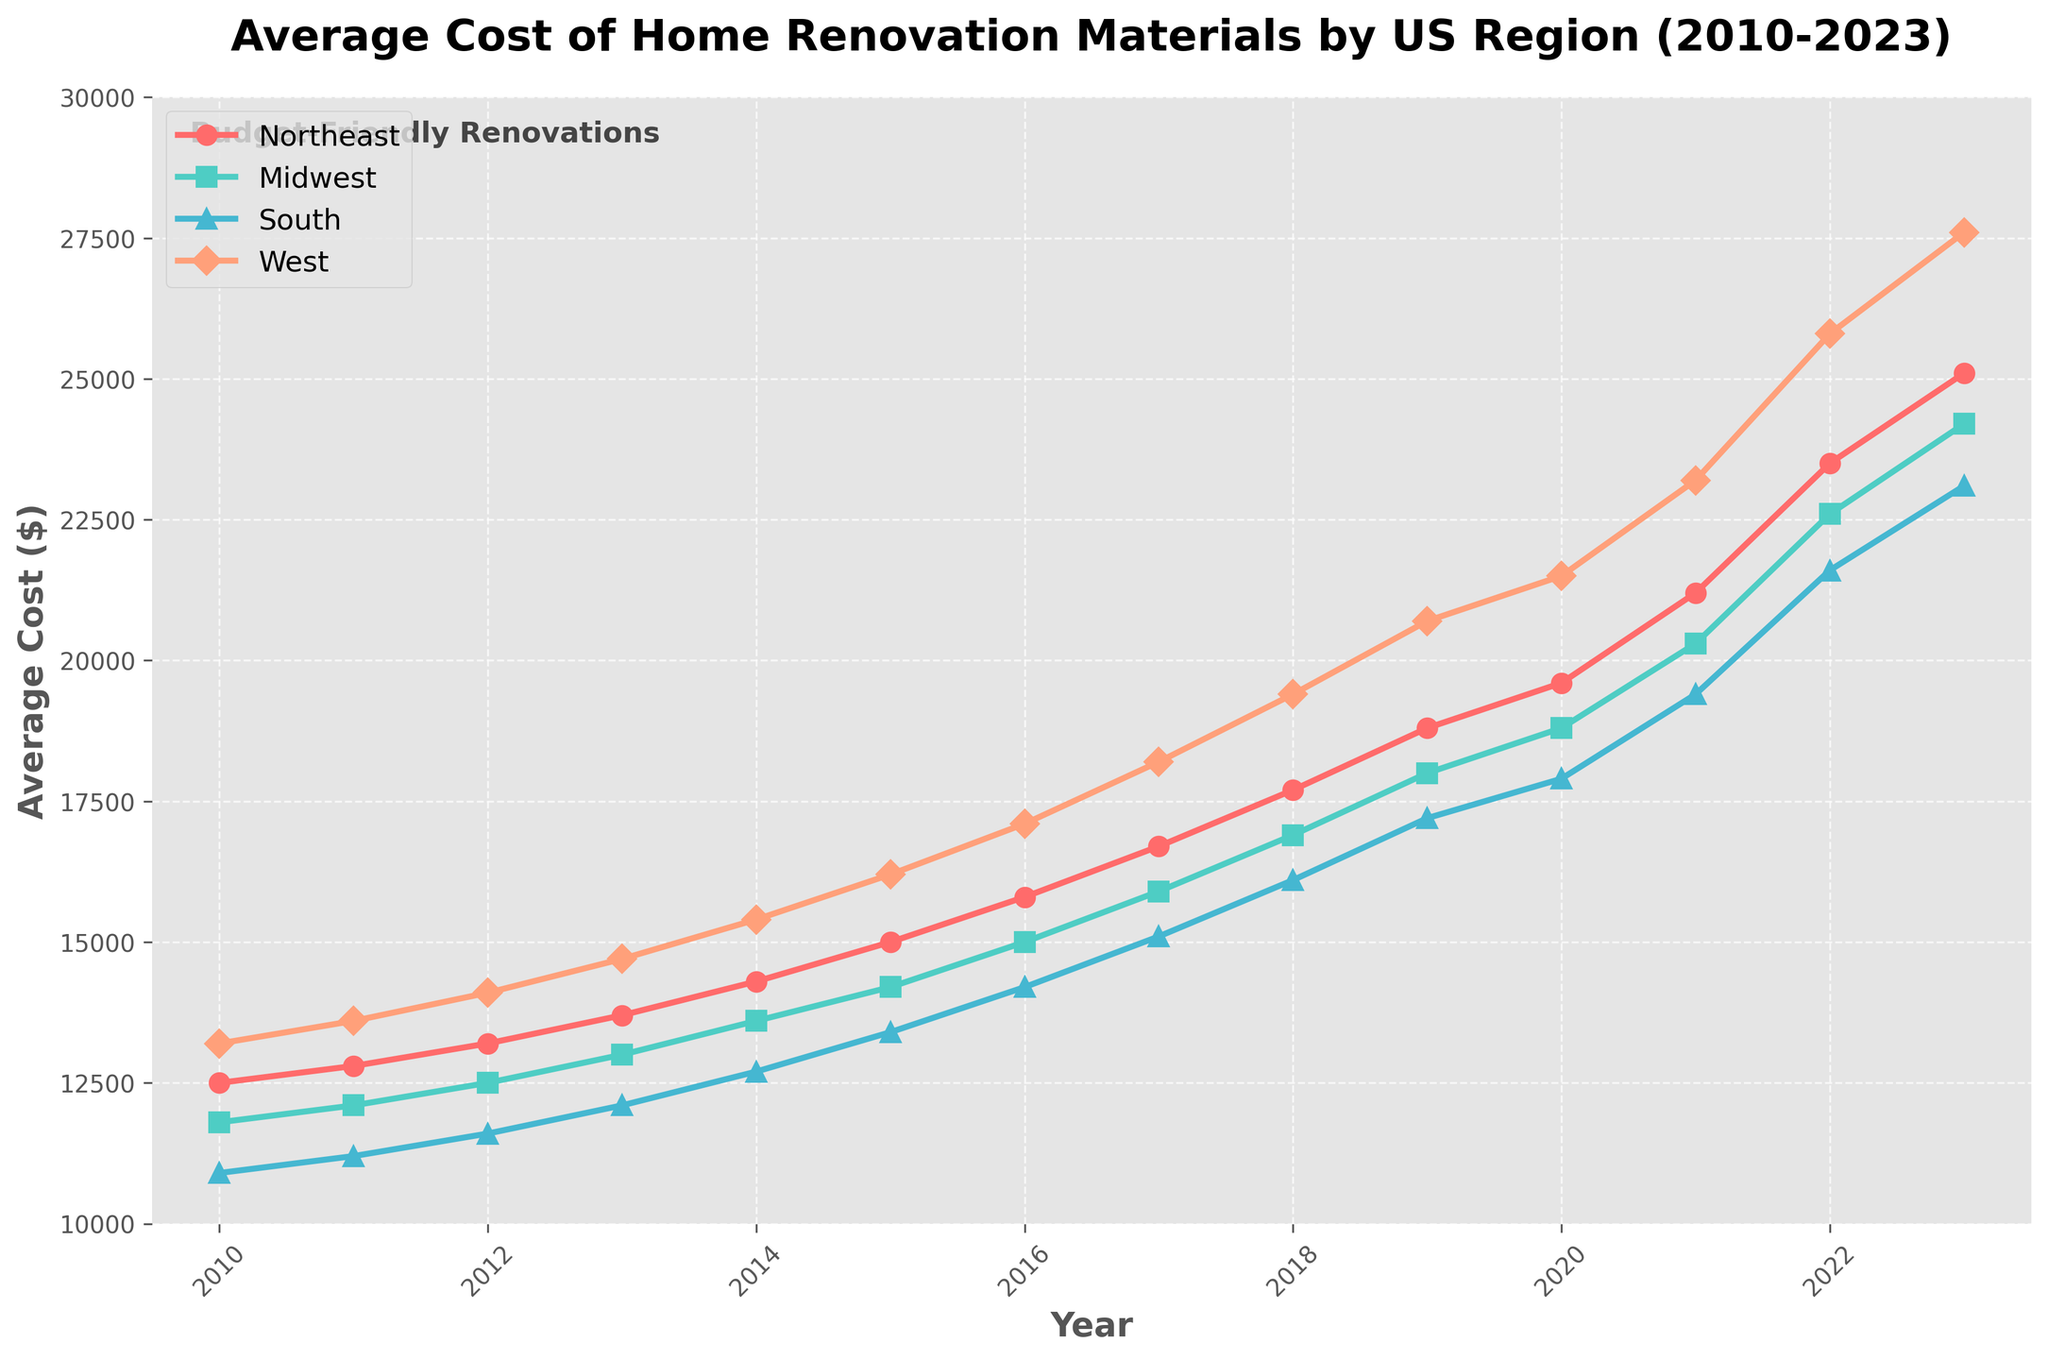What was the average cost of renovation materials in the West region in 2023? To find this, look at the value on the y-axis corresponding to the year 2023 in the West region (orange line). The value is 27600.
Answer: 27600 Which region had the highest cost of renovation materials in 2015? By observing the lines corresponding to each region in 2015, the West region (orange line) reaches the highest point on the y-axis compared to other regions.
Answer: West What is the overall increase in renovation material costs for the South region from 2010 to 2023? To find this, subtract the 2010 value from the 2023 value for the South region. The values are 23100 (2023) and 10900 (2010). Therefore, 23100 - 10900 = 12200.
Answer: 12200 How many years between 2010 to 2023 did the Midwest region have lower renovation material costs than the South region? By comparing the values of the Midwest (green line) and South (blue line) regions from 2010 to 2023, it is observed that the Midwest region had lower costs than the South region in 2010 to 2022. This counts as 13 years (2010-2022).
Answer: 13 years In which year did the Northeast region's renovation material cost exceed 20000 for the first time? To determine this, observe the year on the x-axis where the Northeast region (red line) surpasses 20000 on the y-axis. This happens in 2021.
Answer: 2021 What is the difference in renovation material costs between the Northeast and Midwest regions in 2022? To find this, subtract the value of the Midwest region from the Northeast region in 2022. The values are 23500 (Northeast) and 22600 (Midwest). Therefore, 23500 - 22600 = 900.
Answer: 900 Which region had the smallest increase in renovation material costs from 2010 to 2023? To determine this, calculate the increase for each region by subtracting the 2010 values from the 2023 values. The increases are Northeast: 25100 - 12500 = 12600, Midwest: 24200 - 11800 = 12400, South: 23100 - 10900 = 12200, West: 27600 - 13200 = 14400. The South region has the smallest increase which is 12200.
Answer: South Between the years 2018 and 2020, how much did the renovation material costs in the Midwest region increase? To find this, subtract the 2018 value from the 2020 value for the Midwest region. The values are 18800 (2020) and 16900 (2018). Therefore, 18800 - 16900 = 1900.
Answer: 1900 